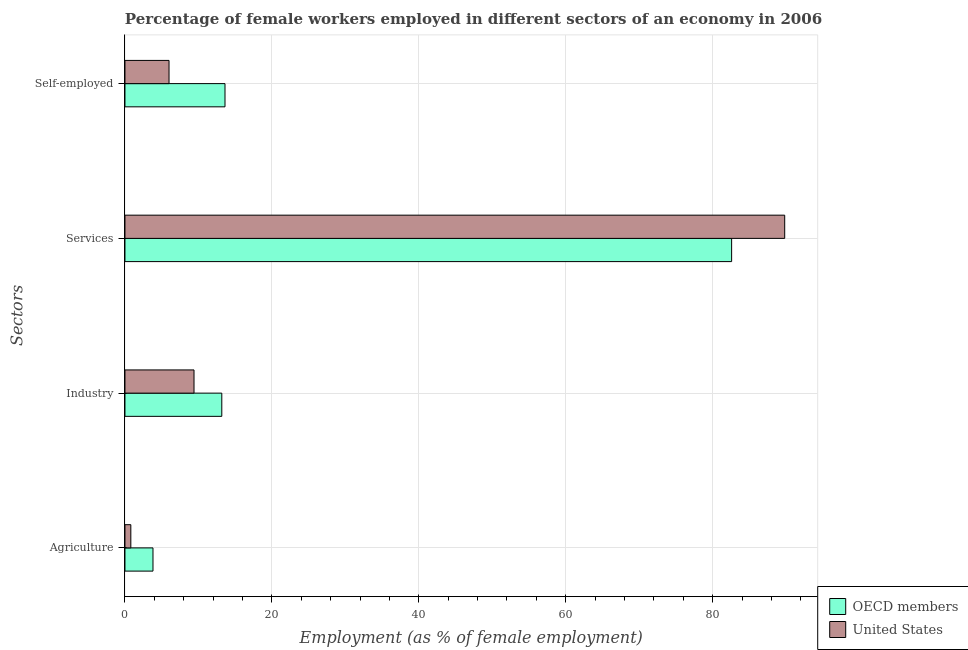How many bars are there on the 2nd tick from the top?
Your answer should be compact. 2. How many bars are there on the 3rd tick from the bottom?
Give a very brief answer. 2. What is the label of the 1st group of bars from the top?
Offer a very short reply. Self-employed. What is the percentage of female workers in industry in OECD members?
Offer a terse response. 13.18. Across all countries, what is the maximum percentage of self employed female workers?
Provide a succinct answer. 13.62. Across all countries, what is the minimum percentage of female workers in services?
Your answer should be very brief. 82.58. In which country was the percentage of female workers in services minimum?
Provide a succinct answer. OECD members. What is the total percentage of female workers in agriculture in the graph?
Your answer should be very brief. 4.62. What is the difference between the percentage of self employed female workers in OECD members and that in United States?
Give a very brief answer. 7.62. What is the difference between the percentage of female workers in agriculture in United States and the percentage of female workers in industry in OECD members?
Give a very brief answer. -12.38. What is the average percentage of female workers in services per country?
Make the answer very short. 86.19. What is the difference between the percentage of female workers in agriculture and percentage of female workers in services in United States?
Offer a very short reply. -89. What is the ratio of the percentage of female workers in industry in United States to that in OECD members?
Your answer should be compact. 0.71. What is the difference between the highest and the second highest percentage of female workers in services?
Ensure brevity in your answer.  7.22. What is the difference between the highest and the lowest percentage of self employed female workers?
Keep it short and to the point. 7.62. In how many countries, is the percentage of self employed female workers greater than the average percentage of self employed female workers taken over all countries?
Give a very brief answer. 1. Is it the case that in every country, the sum of the percentage of female workers in agriculture and percentage of female workers in services is greater than the sum of percentage of self employed female workers and percentage of female workers in industry?
Ensure brevity in your answer.  Yes. What does the 1st bar from the bottom in Industry represents?
Provide a short and direct response. OECD members. Is it the case that in every country, the sum of the percentage of female workers in agriculture and percentage of female workers in industry is greater than the percentage of female workers in services?
Ensure brevity in your answer.  No. How many bars are there?
Make the answer very short. 8. Does the graph contain any zero values?
Provide a succinct answer. No. Where does the legend appear in the graph?
Your answer should be very brief. Bottom right. How many legend labels are there?
Your response must be concise. 2. How are the legend labels stacked?
Your answer should be compact. Vertical. What is the title of the graph?
Offer a very short reply. Percentage of female workers employed in different sectors of an economy in 2006. What is the label or title of the X-axis?
Ensure brevity in your answer.  Employment (as % of female employment). What is the label or title of the Y-axis?
Provide a succinct answer. Sectors. What is the Employment (as % of female employment) in OECD members in Agriculture?
Make the answer very short. 3.82. What is the Employment (as % of female employment) in United States in Agriculture?
Keep it short and to the point. 0.8. What is the Employment (as % of female employment) in OECD members in Industry?
Keep it short and to the point. 13.18. What is the Employment (as % of female employment) in United States in Industry?
Offer a terse response. 9.4. What is the Employment (as % of female employment) in OECD members in Services?
Your response must be concise. 82.58. What is the Employment (as % of female employment) of United States in Services?
Offer a very short reply. 89.8. What is the Employment (as % of female employment) of OECD members in Self-employed?
Provide a succinct answer. 13.62. What is the Employment (as % of female employment) of United States in Self-employed?
Ensure brevity in your answer.  6. Across all Sectors, what is the maximum Employment (as % of female employment) in OECD members?
Offer a very short reply. 82.58. Across all Sectors, what is the maximum Employment (as % of female employment) of United States?
Your answer should be very brief. 89.8. Across all Sectors, what is the minimum Employment (as % of female employment) of OECD members?
Your response must be concise. 3.82. Across all Sectors, what is the minimum Employment (as % of female employment) in United States?
Your answer should be compact. 0.8. What is the total Employment (as % of female employment) in OECD members in the graph?
Provide a short and direct response. 113.19. What is the total Employment (as % of female employment) in United States in the graph?
Your answer should be very brief. 106. What is the difference between the Employment (as % of female employment) in OECD members in Agriculture and that in Industry?
Provide a short and direct response. -9.37. What is the difference between the Employment (as % of female employment) of OECD members in Agriculture and that in Services?
Keep it short and to the point. -78.76. What is the difference between the Employment (as % of female employment) of United States in Agriculture and that in Services?
Make the answer very short. -89. What is the difference between the Employment (as % of female employment) in OECD members in Agriculture and that in Self-employed?
Offer a terse response. -9.8. What is the difference between the Employment (as % of female employment) in OECD members in Industry and that in Services?
Keep it short and to the point. -69.39. What is the difference between the Employment (as % of female employment) of United States in Industry and that in Services?
Your response must be concise. -80.4. What is the difference between the Employment (as % of female employment) in OECD members in Industry and that in Self-employed?
Make the answer very short. -0.44. What is the difference between the Employment (as % of female employment) in OECD members in Services and that in Self-employed?
Make the answer very short. 68.96. What is the difference between the Employment (as % of female employment) of United States in Services and that in Self-employed?
Provide a short and direct response. 83.8. What is the difference between the Employment (as % of female employment) of OECD members in Agriculture and the Employment (as % of female employment) of United States in Industry?
Your answer should be very brief. -5.58. What is the difference between the Employment (as % of female employment) in OECD members in Agriculture and the Employment (as % of female employment) in United States in Services?
Offer a very short reply. -85.98. What is the difference between the Employment (as % of female employment) of OECD members in Agriculture and the Employment (as % of female employment) of United States in Self-employed?
Make the answer very short. -2.18. What is the difference between the Employment (as % of female employment) of OECD members in Industry and the Employment (as % of female employment) of United States in Services?
Make the answer very short. -76.62. What is the difference between the Employment (as % of female employment) of OECD members in Industry and the Employment (as % of female employment) of United States in Self-employed?
Offer a terse response. 7.18. What is the difference between the Employment (as % of female employment) of OECD members in Services and the Employment (as % of female employment) of United States in Self-employed?
Your response must be concise. 76.58. What is the average Employment (as % of female employment) of OECD members per Sectors?
Provide a succinct answer. 28.3. What is the average Employment (as % of female employment) of United States per Sectors?
Your answer should be very brief. 26.5. What is the difference between the Employment (as % of female employment) of OECD members and Employment (as % of female employment) of United States in Agriculture?
Provide a succinct answer. 3.02. What is the difference between the Employment (as % of female employment) of OECD members and Employment (as % of female employment) of United States in Industry?
Keep it short and to the point. 3.78. What is the difference between the Employment (as % of female employment) in OECD members and Employment (as % of female employment) in United States in Services?
Your answer should be very brief. -7.22. What is the difference between the Employment (as % of female employment) in OECD members and Employment (as % of female employment) in United States in Self-employed?
Your response must be concise. 7.62. What is the ratio of the Employment (as % of female employment) of OECD members in Agriculture to that in Industry?
Provide a short and direct response. 0.29. What is the ratio of the Employment (as % of female employment) in United States in Agriculture to that in Industry?
Your answer should be very brief. 0.09. What is the ratio of the Employment (as % of female employment) of OECD members in Agriculture to that in Services?
Ensure brevity in your answer.  0.05. What is the ratio of the Employment (as % of female employment) in United States in Agriculture to that in Services?
Keep it short and to the point. 0.01. What is the ratio of the Employment (as % of female employment) in OECD members in Agriculture to that in Self-employed?
Make the answer very short. 0.28. What is the ratio of the Employment (as % of female employment) of United States in Agriculture to that in Self-employed?
Make the answer very short. 0.13. What is the ratio of the Employment (as % of female employment) in OECD members in Industry to that in Services?
Your response must be concise. 0.16. What is the ratio of the Employment (as % of female employment) of United States in Industry to that in Services?
Offer a very short reply. 0.1. What is the ratio of the Employment (as % of female employment) of United States in Industry to that in Self-employed?
Provide a succinct answer. 1.57. What is the ratio of the Employment (as % of female employment) in OECD members in Services to that in Self-employed?
Give a very brief answer. 6.06. What is the ratio of the Employment (as % of female employment) in United States in Services to that in Self-employed?
Make the answer very short. 14.97. What is the difference between the highest and the second highest Employment (as % of female employment) in OECD members?
Make the answer very short. 68.96. What is the difference between the highest and the second highest Employment (as % of female employment) in United States?
Offer a terse response. 80.4. What is the difference between the highest and the lowest Employment (as % of female employment) in OECD members?
Your response must be concise. 78.76. What is the difference between the highest and the lowest Employment (as % of female employment) in United States?
Your answer should be very brief. 89. 